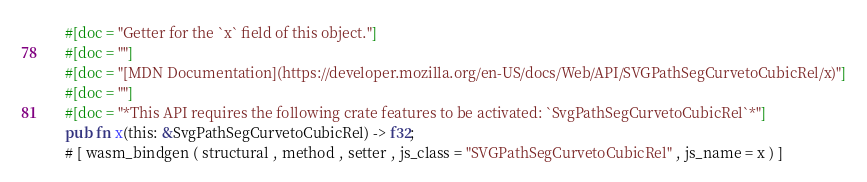Convert code to text. <code><loc_0><loc_0><loc_500><loc_500><_Rust_>    #[doc = "Getter for the `x` field of this object."]
    #[doc = ""]
    #[doc = "[MDN Documentation](https://developer.mozilla.org/en-US/docs/Web/API/SVGPathSegCurvetoCubicRel/x)"]
    #[doc = ""]
    #[doc = "*This API requires the following crate features to be activated: `SvgPathSegCurvetoCubicRel`*"]
    pub fn x(this: &SvgPathSegCurvetoCubicRel) -> f32;
    # [ wasm_bindgen ( structural , method , setter , js_class = "SVGPathSegCurvetoCubicRel" , js_name = x ) ]</code> 